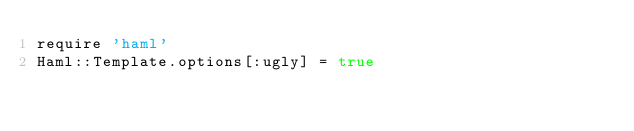<code> <loc_0><loc_0><loc_500><loc_500><_Ruby_>require 'haml'
Haml::Template.options[:ugly] = true
</code> 